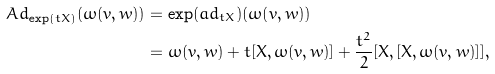Convert formula to latex. <formula><loc_0><loc_0><loc_500><loc_500>A d _ { \exp ( t X ) } ( \omega ( v , w ) ) & = \exp ( a d _ { t X } ) ( \omega ( v , w ) ) \\ & = \omega ( v , w ) + t [ X , \omega ( v , w ) ] + \frac { t ^ { 2 } } { 2 } [ X , [ X , \omega ( v , w ) ] ] ,</formula> 